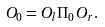<formula> <loc_0><loc_0><loc_500><loc_500>O _ { 0 } = O _ { l } \Pi _ { 0 } O _ { r } .</formula> 